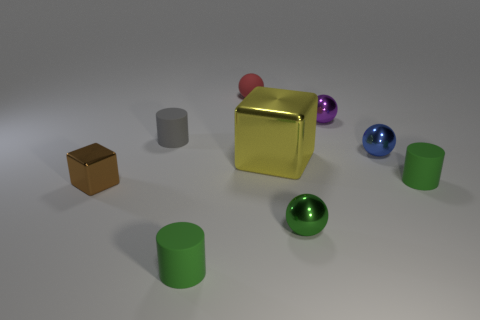Can you tell me what the largest object in the scene is, and what color it appears to be? The largest object in the image is the central cube, which has a striking golden color. 